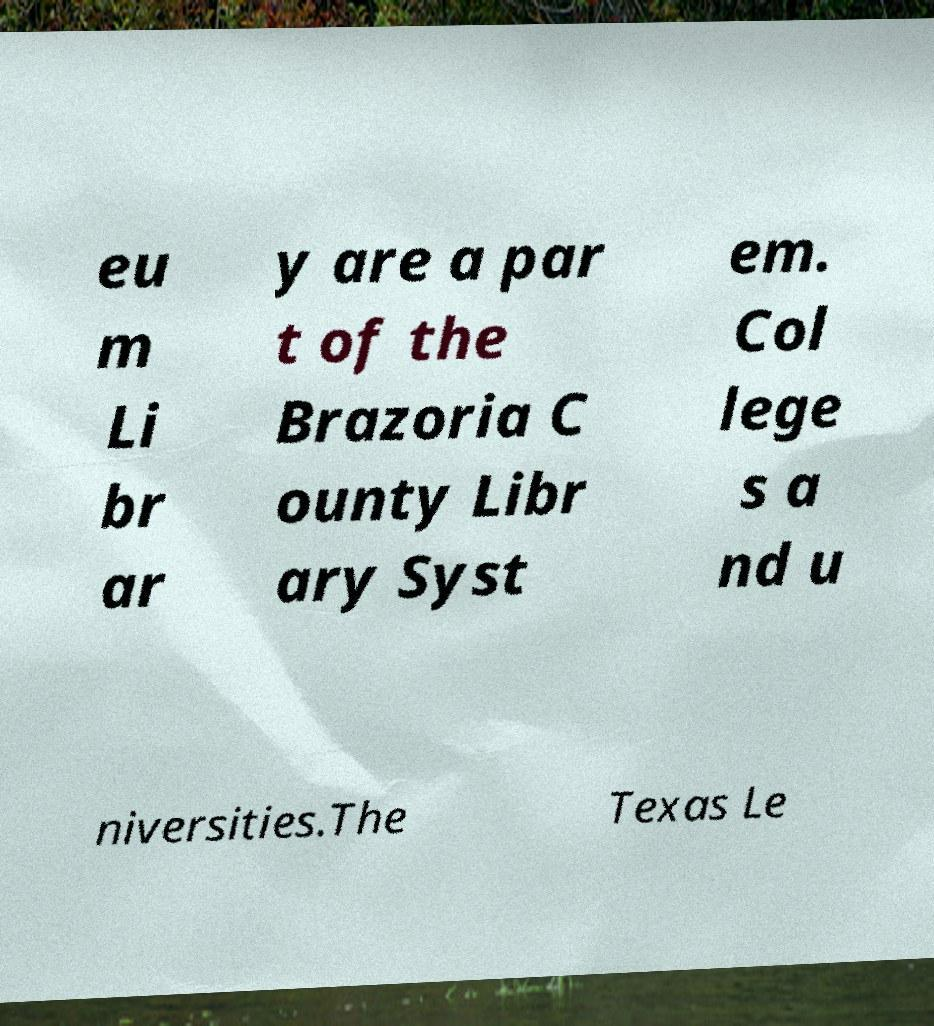I need the written content from this picture converted into text. Can you do that? eu m Li br ar y are a par t of the Brazoria C ounty Libr ary Syst em. Col lege s a nd u niversities.The Texas Le 